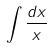<formula> <loc_0><loc_0><loc_500><loc_500>\int \frac { d x } { x }</formula> 